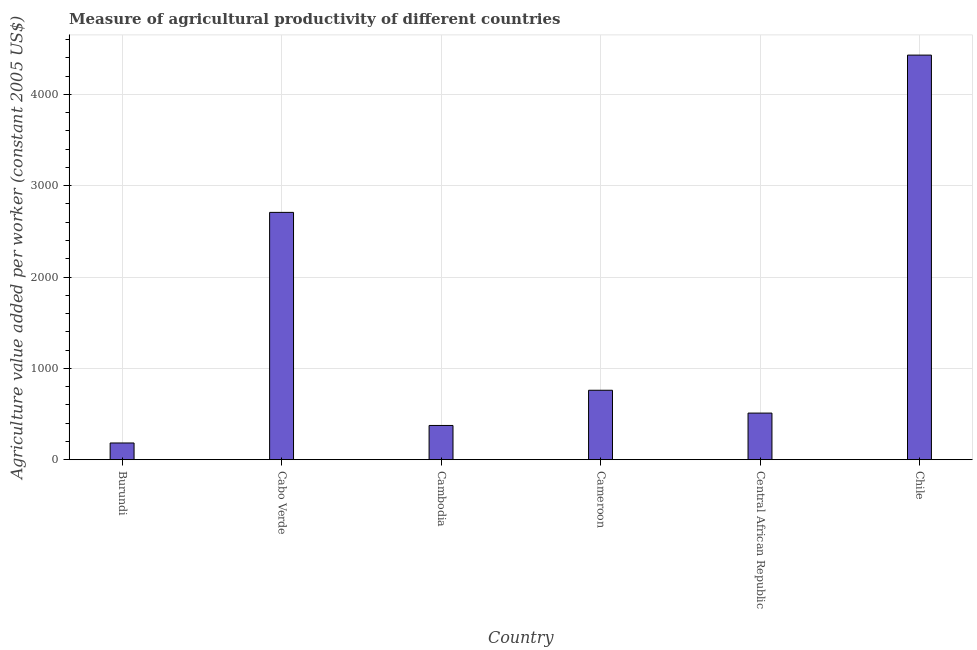Does the graph contain any zero values?
Make the answer very short. No. What is the title of the graph?
Ensure brevity in your answer.  Measure of agricultural productivity of different countries. What is the label or title of the X-axis?
Offer a very short reply. Country. What is the label or title of the Y-axis?
Give a very brief answer. Agriculture value added per worker (constant 2005 US$). What is the agriculture value added per worker in Cambodia?
Your response must be concise. 374.78. Across all countries, what is the maximum agriculture value added per worker?
Your response must be concise. 4429.45. Across all countries, what is the minimum agriculture value added per worker?
Provide a short and direct response. 183.06. In which country was the agriculture value added per worker maximum?
Keep it short and to the point. Chile. In which country was the agriculture value added per worker minimum?
Keep it short and to the point. Burundi. What is the sum of the agriculture value added per worker?
Provide a short and direct response. 8965.51. What is the difference between the agriculture value added per worker in Burundi and Cameroon?
Offer a terse response. -577.22. What is the average agriculture value added per worker per country?
Your answer should be compact. 1494.25. What is the median agriculture value added per worker?
Provide a short and direct response. 635.31. In how many countries, is the agriculture value added per worker greater than 2600 US$?
Provide a succinct answer. 2. What is the ratio of the agriculture value added per worker in Cabo Verde to that in Central African Republic?
Your answer should be very brief. 5.31. Is the agriculture value added per worker in Cabo Verde less than that in Cameroon?
Provide a succinct answer. No. Is the difference between the agriculture value added per worker in Cameroon and Central African Republic greater than the difference between any two countries?
Offer a very short reply. No. What is the difference between the highest and the second highest agriculture value added per worker?
Offer a very short reply. 1721.85. Is the sum of the agriculture value added per worker in Cambodia and Central African Republic greater than the maximum agriculture value added per worker across all countries?
Provide a short and direct response. No. What is the difference between the highest and the lowest agriculture value added per worker?
Provide a succinct answer. 4246.39. In how many countries, is the agriculture value added per worker greater than the average agriculture value added per worker taken over all countries?
Ensure brevity in your answer.  2. How many bars are there?
Provide a succinct answer. 6. How many countries are there in the graph?
Give a very brief answer. 6. What is the difference between two consecutive major ticks on the Y-axis?
Provide a short and direct response. 1000. What is the Agriculture value added per worker (constant 2005 US$) in Burundi?
Your response must be concise. 183.06. What is the Agriculture value added per worker (constant 2005 US$) in Cabo Verde?
Your response must be concise. 2707.6. What is the Agriculture value added per worker (constant 2005 US$) in Cambodia?
Make the answer very short. 374.78. What is the Agriculture value added per worker (constant 2005 US$) of Cameroon?
Your answer should be compact. 760.28. What is the Agriculture value added per worker (constant 2005 US$) of Central African Republic?
Give a very brief answer. 510.33. What is the Agriculture value added per worker (constant 2005 US$) of Chile?
Make the answer very short. 4429.45. What is the difference between the Agriculture value added per worker (constant 2005 US$) in Burundi and Cabo Verde?
Keep it short and to the point. -2524.54. What is the difference between the Agriculture value added per worker (constant 2005 US$) in Burundi and Cambodia?
Provide a succinct answer. -191.72. What is the difference between the Agriculture value added per worker (constant 2005 US$) in Burundi and Cameroon?
Provide a succinct answer. -577.22. What is the difference between the Agriculture value added per worker (constant 2005 US$) in Burundi and Central African Republic?
Your answer should be compact. -327.26. What is the difference between the Agriculture value added per worker (constant 2005 US$) in Burundi and Chile?
Your answer should be compact. -4246.39. What is the difference between the Agriculture value added per worker (constant 2005 US$) in Cabo Verde and Cambodia?
Your answer should be compact. 2332.82. What is the difference between the Agriculture value added per worker (constant 2005 US$) in Cabo Verde and Cameroon?
Your answer should be compact. 1947.32. What is the difference between the Agriculture value added per worker (constant 2005 US$) in Cabo Verde and Central African Republic?
Ensure brevity in your answer.  2197.28. What is the difference between the Agriculture value added per worker (constant 2005 US$) in Cabo Verde and Chile?
Make the answer very short. -1721.85. What is the difference between the Agriculture value added per worker (constant 2005 US$) in Cambodia and Cameroon?
Your answer should be compact. -385.5. What is the difference between the Agriculture value added per worker (constant 2005 US$) in Cambodia and Central African Republic?
Keep it short and to the point. -135.54. What is the difference between the Agriculture value added per worker (constant 2005 US$) in Cambodia and Chile?
Ensure brevity in your answer.  -4054.67. What is the difference between the Agriculture value added per worker (constant 2005 US$) in Cameroon and Central African Republic?
Your answer should be very brief. 249.96. What is the difference between the Agriculture value added per worker (constant 2005 US$) in Cameroon and Chile?
Your answer should be very brief. -3669.17. What is the difference between the Agriculture value added per worker (constant 2005 US$) in Central African Republic and Chile?
Offer a very short reply. -3919.13. What is the ratio of the Agriculture value added per worker (constant 2005 US$) in Burundi to that in Cabo Verde?
Ensure brevity in your answer.  0.07. What is the ratio of the Agriculture value added per worker (constant 2005 US$) in Burundi to that in Cambodia?
Your response must be concise. 0.49. What is the ratio of the Agriculture value added per worker (constant 2005 US$) in Burundi to that in Cameroon?
Keep it short and to the point. 0.24. What is the ratio of the Agriculture value added per worker (constant 2005 US$) in Burundi to that in Central African Republic?
Offer a very short reply. 0.36. What is the ratio of the Agriculture value added per worker (constant 2005 US$) in Burundi to that in Chile?
Your answer should be very brief. 0.04. What is the ratio of the Agriculture value added per worker (constant 2005 US$) in Cabo Verde to that in Cambodia?
Your answer should be compact. 7.22. What is the ratio of the Agriculture value added per worker (constant 2005 US$) in Cabo Verde to that in Cameroon?
Provide a short and direct response. 3.56. What is the ratio of the Agriculture value added per worker (constant 2005 US$) in Cabo Verde to that in Central African Republic?
Offer a terse response. 5.31. What is the ratio of the Agriculture value added per worker (constant 2005 US$) in Cabo Verde to that in Chile?
Offer a terse response. 0.61. What is the ratio of the Agriculture value added per worker (constant 2005 US$) in Cambodia to that in Cameroon?
Offer a terse response. 0.49. What is the ratio of the Agriculture value added per worker (constant 2005 US$) in Cambodia to that in Central African Republic?
Give a very brief answer. 0.73. What is the ratio of the Agriculture value added per worker (constant 2005 US$) in Cambodia to that in Chile?
Offer a very short reply. 0.09. What is the ratio of the Agriculture value added per worker (constant 2005 US$) in Cameroon to that in Central African Republic?
Make the answer very short. 1.49. What is the ratio of the Agriculture value added per worker (constant 2005 US$) in Cameroon to that in Chile?
Provide a short and direct response. 0.17. What is the ratio of the Agriculture value added per worker (constant 2005 US$) in Central African Republic to that in Chile?
Keep it short and to the point. 0.12. 